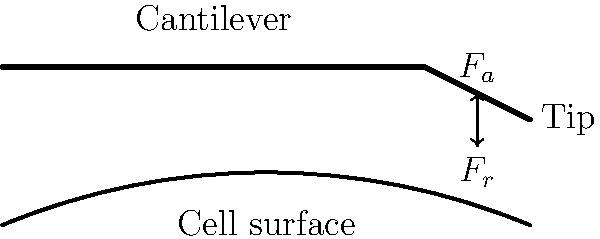In atomic force microscopy (AFM) for imaging cell surfaces, how does the attractive force ($F_a$) between the AFM tip and the cell surface relate to the repulsive force ($F_r$) when the cantilever is at equilibrium during contact mode imaging? To understand the force distribution in atomic force microscopy for imaging cell surfaces, let's follow these steps:

1. In contact mode AFM, the tip is in constant contact with the cell surface.

2. The cantilever deflection is maintained at a constant setpoint by adjusting the z-position of the cantilever.

3. At equilibrium, the forces acting on the AFM tip must balance out:

   a) $F_a$: Attractive force between the tip and the cell surface (e.g., van der Waals forces)
   b) $F_r$: Repulsive force from the cell surface
   c) $F_c$: Force exerted by the cantilever on the tip

4. The force balance equation at equilibrium is:

   $$F_c = F_r - F_a$$

5. For the cantilever to maintain contact with the surface, the net force must be slightly repulsive. This means:

   $$F_r > F_a$$

6. The difference between $F_r$ and $F_a$ is equal to the force exerted by the cantilever:

   $$F_c = F_r - F_a > 0$$

7. At equilibrium, this difference is constant and corresponds to the setpoint deflection of the cantilever.

Therefore, at equilibrium during contact mode imaging, the repulsive force ($F_r$) is slightly larger than the attractive force ($F_a$), with their difference being equal to the constant force exerted by the cantilever.
Answer: $F_r > F_a$, with $F_r - F_a = F_c$ (constant) 